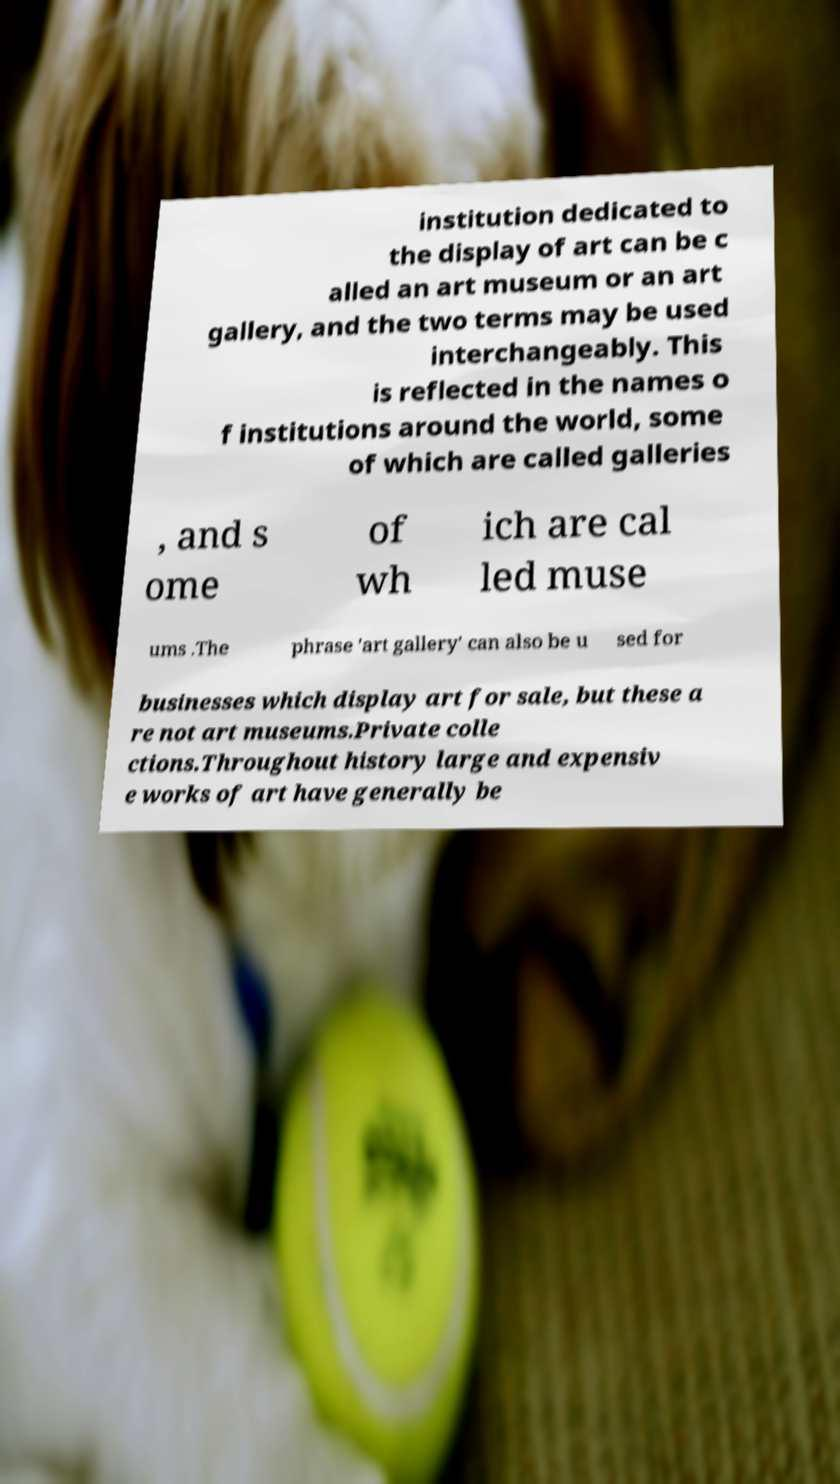Can you read and provide the text displayed in the image?This photo seems to have some interesting text. Can you extract and type it out for me? institution dedicated to the display of art can be c alled an art museum or an art gallery, and the two terms may be used interchangeably. This is reflected in the names o f institutions around the world, some of which are called galleries , and s ome of wh ich are cal led muse ums .The phrase 'art gallery' can also be u sed for businesses which display art for sale, but these a re not art museums.Private colle ctions.Throughout history large and expensiv e works of art have generally be 